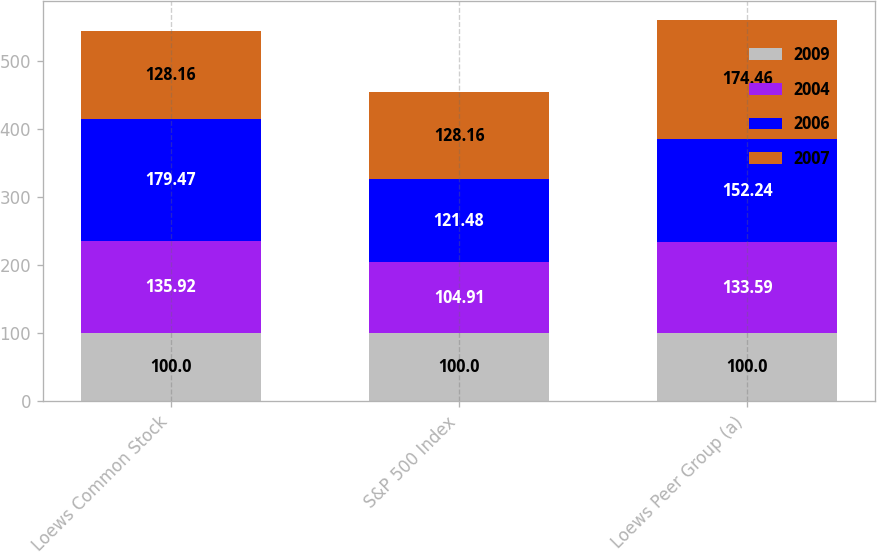Convert chart. <chart><loc_0><loc_0><loc_500><loc_500><stacked_bar_chart><ecel><fcel>Loews Common Stock<fcel>S&P 500 Index<fcel>Loews Peer Group (a)<nl><fcel>2009<fcel>100<fcel>100<fcel>100<nl><fcel>2004<fcel>135.92<fcel>104.91<fcel>133.59<nl><fcel>2006<fcel>179.47<fcel>121.48<fcel>152.24<nl><fcel>2007<fcel>128.16<fcel>128.16<fcel>174.46<nl></chart> 